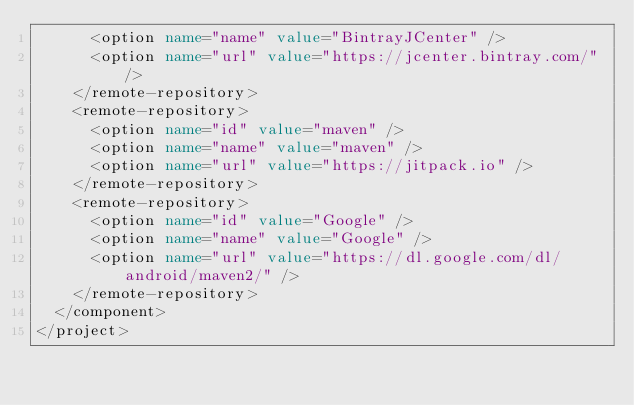Convert code to text. <code><loc_0><loc_0><loc_500><loc_500><_XML_>      <option name="name" value="BintrayJCenter" />
      <option name="url" value="https://jcenter.bintray.com/" />
    </remote-repository>
    <remote-repository>
      <option name="id" value="maven" />
      <option name="name" value="maven" />
      <option name="url" value="https://jitpack.io" />
    </remote-repository>
    <remote-repository>
      <option name="id" value="Google" />
      <option name="name" value="Google" />
      <option name="url" value="https://dl.google.com/dl/android/maven2/" />
    </remote-repository>
  </component>
</project></code> 